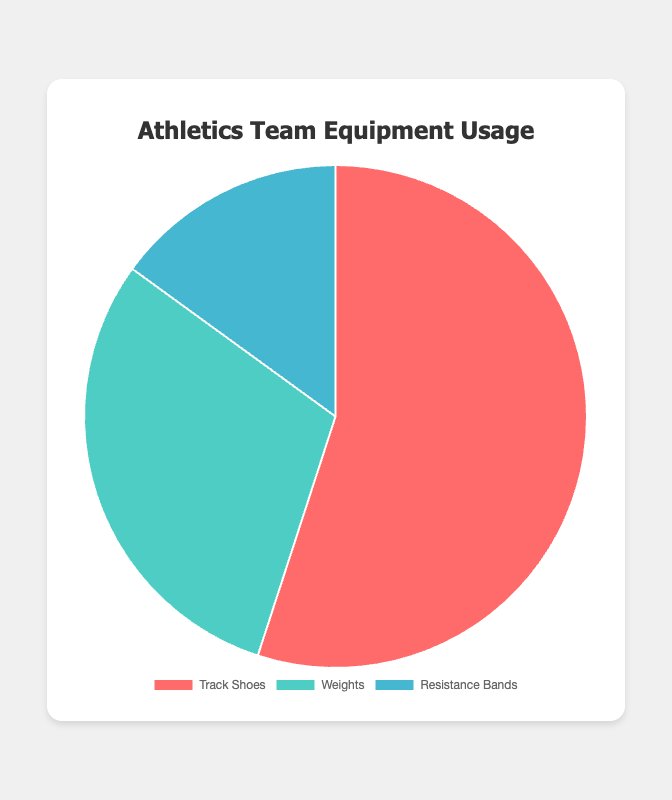What is the most used equipment on the athletics team? The figure shows that the Track Shoes have the largest percentage of usage at 55%.
Answer: Track Shoes What percentage of equipment usage is not Track Shoes? The total percentage of equipment usage is 100%. Subtracting the usage of Track Shoes (55%) from the total gives 100% - 55% = 45%.
Answer: 45% Which equipment is used more, Weights or Resistance Bands? From the figure, Weights have a usage percentage of 30%, and Resistance Bands have a usage percentage of 15%. Since 30% is greater than 15%, Weights are used more.
Answer: Weights What is the total usage percentage for Weights and Resistance Bands combined? Add the usage percentages of Weights (30%) and Resistance Bands (15%). The total is 30% + 15% = 45%.
Answer: 45% How much more is the usage of Track Shoes compared to Resistance Bands? Subtract the usage percentage of Resistance Bands (15%) from Track Shoes (55%). The difference is 55% - 15% = 40%.
Answer: 40% What color represents the usage of Weights in the chart? The visual information in the chart shows that the segment representing Weights is colored in green.
Answer: Green Among the listed equipment, which has the smallest usage percentage? The figure shows the usage percentages, and the smallest one is for Resistance Bands at 15%.
Answer: Resistance Bands Is the usage percentage of Weights less than half that of Track Shoes? Track Shoes have a usage percentage of 55%, while Weights have a usage percentage of 30%. Half of 55% is 27.5%, and since 30% is greater than 27.5%, Weights is not less than half of Track Shoes.
Answer: No If you were to exclude Track Shoes, what would be the new percentage distribution of Weights and Resistance Bands? Without Track Shoes, the total percentage for Weights (30%) and Resistance Bands (15%) would be recalculated to a new total of 45%. The new percentage for Weights is (30/45) * 100 = 66.67%, and for Resistance Bands it’s (15/45) * 100 = 33.33%.
Answer: Weights: 66.67%, Resistance Bands: 33.33% What is the average usage percentage of all the equipment listed? Sum the usage percentages of all the equipment: 55% + 30% + 15% = 100%. Divide by the number of equipment (3). The average usage percentage is 100% / 3 ≈ 33.33%.
Answer: 33.33% 